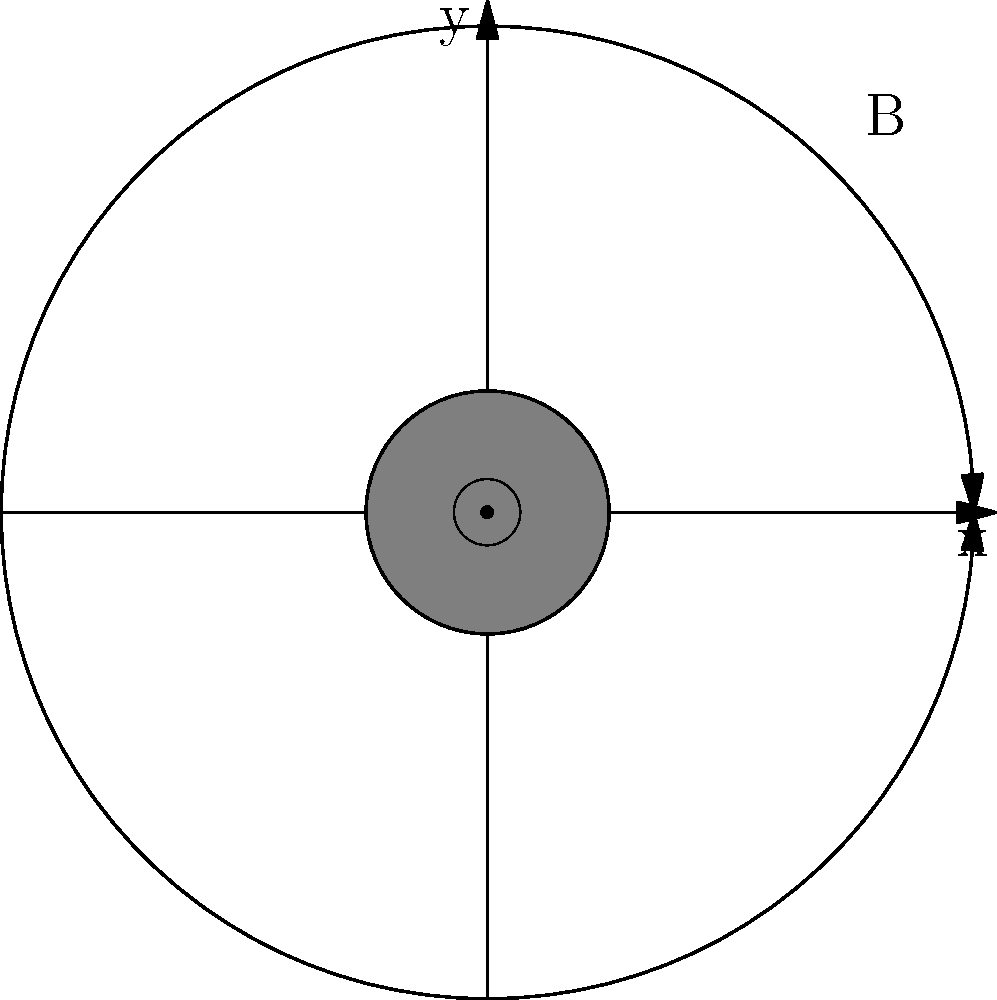In the cross-sectional view of a current-carrying wire shown above, the current is flowing out of the page (represented by the $\odot$ symbol). Given your expertise in cellular structures, how would you describe the relationship between the direction of the current and the magnetic field lines, and what fundamental principle of electromagnetism does this illustrate? To answer this question, let's break it down step-by-step:

1. Current direction: The $\odot$ symbol indicates that the current is flowing out of the page, towards the observer.

2. Magnetic field lines: The circular arrows represent the magnetic field lines around the wire.

3. Direction of magnetic field: Using the right-hand rule for a straight current-carrying wire:
   - Imagine grasping the wire with your right hand, with your thumb pointing in the direction of the current (out of the page in this case).
   - Your fingers will naturally curl in the direction of the magnetic field lines.

4. Observation: The magnetic field lines are indeed circling the wire in a counterclockwise direction, consistent with the right-hand rule.

5. Principle illustrated: This demonstrates Ampère's circuital law, which states that a current creates a magnetic field that encircles the current.

6. Analogy to cell biology: Just as the current in the wire induces a surrounding magnetic field, certain cellular processes (like ion channels or membrane potentials) can create electromagnetic fields that influence the surrounding cellular environment.

7. Relevance to synthetic tissue engineering: Understanding these electromagnetic principles at the cellular level can be crucial for developing synthetic tissues that mimic natural bioelectric properties, potentially influencing cell behavior, differentiation, and tissue function.
Answer: The magnetic field lines circulate counterclockwise around the wire carrying current out of the page, illustrating Ampère's circuital law. 